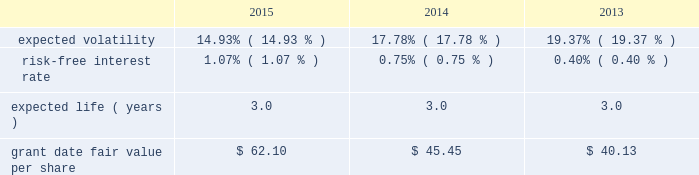During 2012 , the company granted selected employees an aggregate of 139 thousand rsus with internal performance measures and , separately , certain market thresholds .
These awards vested in january 2015 .
The terms of the grants specified that to the extent certain performance goals , comprised of internal measures and , separately , market thresholds were achieved , the rsus would vest ; if performance goals were surpassed , up to 175% ( 175 % ) of the target awards would be distributed ; and if performance goals were not met , the awards would be forfeited .
In january 2015 , an additional 93 thousand rsus were granted and distributed because performance thresholds were exceeded .
In 2015 , 2014 and 2013 , the company granted rsus , both with and without performance conditions , to certain employees under the 2007 plan .
The rsus without performance conditions vest ratably over the three- year service period beginning january 1 of the year of the grant and the rsus with performance conditions vest ratably over the three-year performance period beginning january 1 of the year of the grant ( the 201cperformance period 201d ) .
Distribution of the performance shares is contingent upon the achievement of internal performance measures and , separately , certain market thresholds over the performance period .
During 2015 , 2014 and 2013 , the company granted rsus to non-employee directors under the 2007 plan .
The rsus vested on the date of grant ; however , distribution of the shares will be made within 30 days of the earlier of : ( i ) 15 months after grant date , subject to any deferral election by the director ; or ( ii ) the participant 2019s separation from service .
Because these rsus vested on the grant date , the total grant date fair value was recorded in operation and maintenance expense included in the expense table above on the grant date .
Rsus generally vest over periods ranging from one to three years .
Rsus granted with service-only conditions and those with internal performance measures are valued at the market value of the closing price of the company 2019s common stock on the date of grant .
Rsus granted with market conditions are valued using a monte carlo model .
Expected volatility is based on historical volatilities of traded common stock of the company and comparative companies using daily stock prices over the past three years .
The expected term is three years and the risk-free interest rate is based on the three-year u.s .
Treasury rate in effect as of the measurement date .
The table presents the weighted-average assumptions used in the monte carlo simulation and the weighted-average grant date fair values of rsus granted for the years ended december 31: .
The grant date fair value of restricted stock awards that vest ratably and have market and/or performance and service conditions are amortized through expense over the requisite service period using the graded-vesting method .
Rsus that have no performance conditions are amortized through expense over the requisite service period using the straight-line method and are included in operations expense in the accompanying consolidated statements of operations .
As of december 31 , 2015 , $ 4 of total unrecognized compensation cost related to the nonvested restricted stock units is expected to be recognized over the weighted-average remaining life of 1.4 years .
The total grant date fair value of rsus vested was $ 12 , $ 11 and $ 9 for the years ended december 31 , 2015 , 2014 and 2013. .
By what percentage did grant date fair value per share increase from 2013 to 2015? 
Computations: ((62.10 - 40.13) / 40.13)
Answer: 0.54747. 